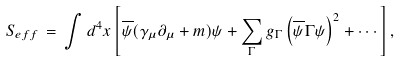Convert formula to latex. <formula><loc_0><loc_0><loc_500><loc_500>S _ { e f f } \, = \, \int d ^ { 4 } x \left [ \overline { \psi } ( \gamma _ { \mu } \partial _ { \mu } + m ) \psi + \sum _ { \Gamma } g _ { \Gamma } \left ( \overline { \psi } \Gamma \psi \right ) ^ { 2 } + \cdots \right ] ,</formula> 